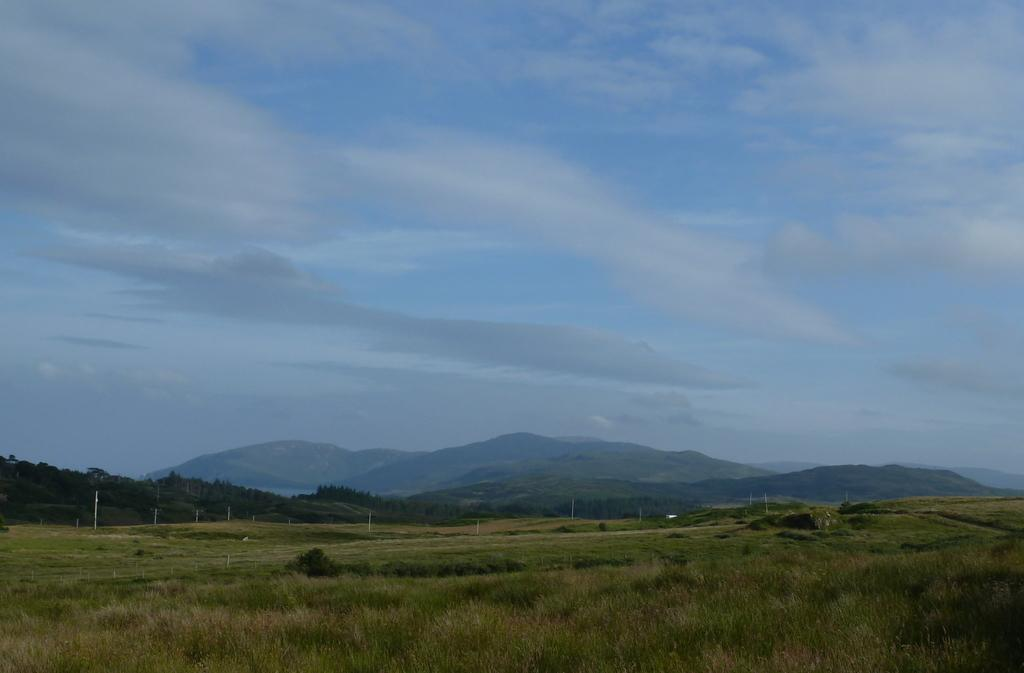What type of living organisms can be seen in the image? Plants and trees are visible in the image. What man-made structures can be seen in the image? Electric poles are present in the image. What natural features can be seen in the background of the image? Mountains are visible in the background of the image. What is the condition of the sky in the background of the image? The sky is clear in the background of the image. What type of cheese is being served for lunch in the image? There is no mention of lunch or cheese in the image; it features plants, electric poles, trees, mountains, and a clear sky. How many mice can be seen playing with the wax in the image? There are no mice or wax present in the image. 